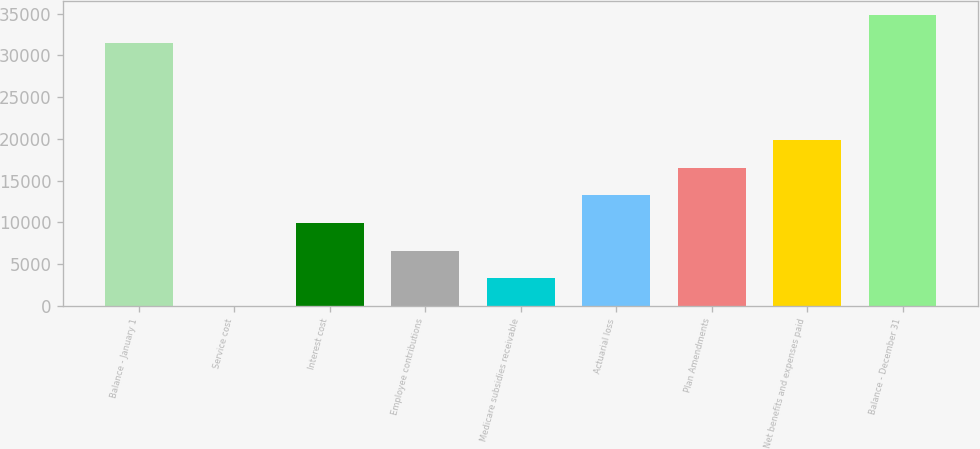Convert chart. <chart><loc_0><loc_0><loc_500><loc_500><bar_chart><fcel>Balance - January 1<fcel>Service cost<fcel>Interest cost<fcel>Employee contributions<fcel>Medicare subsidies receivable<fcel>Actuarial loss<fcel>Plan Amendments<fcel>Net benefits and expenses paid<fcel>Balance - December 31<nl><fcel>31477<fcel>3<fcel>9907.8<fcel>6606.2<fcel>3304.6<fcel>13209.4<fcel>16511<fcel>19812.6<fcel>34778.6<nl></chart> 